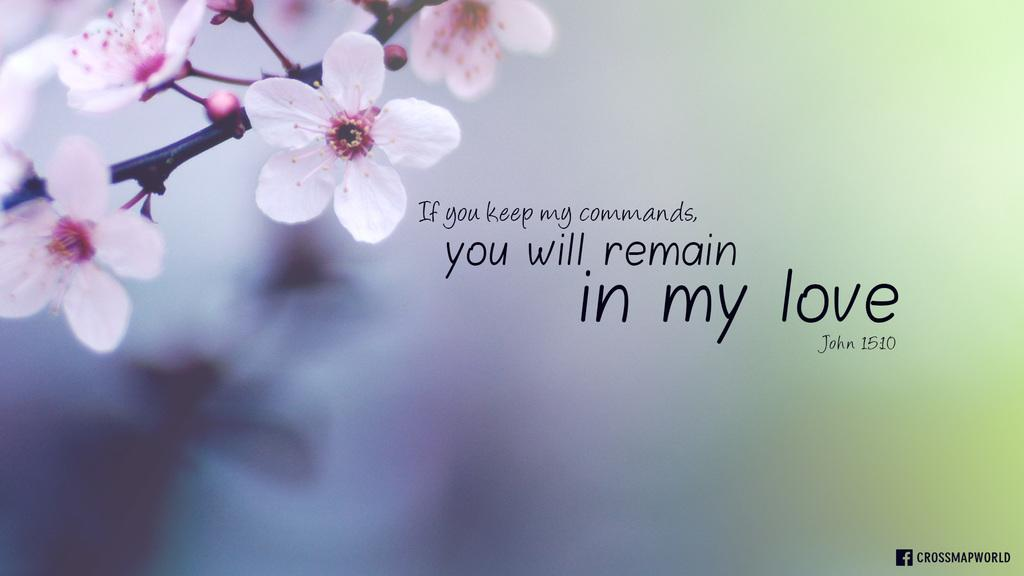What is the main subject of the image? The main subject of the image is a part of a stem with flowers. Are there any words or letters visible in the image? Yes, there is text visible in the image. Can you describe the background of the image? The background of the image is not clear. What type of toothbrush can be seen in the image? There is no toothbrush present in the image. Is there any sleet visible in the image? There is no mention of sleet or any weather-related elements in the provided facts, so it cannot be determined from the image. 